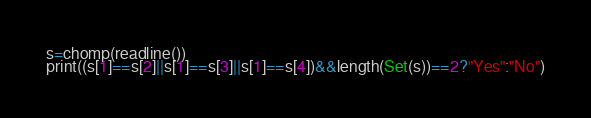Convert code to text. <code><loc_0><loc_0><loc_500><loc_500><_Julia_>s=chomp(readline())
print((s[1]==s[2]||s[1]==s[3]||s[1]==s[4])&&length(Set(s))==2?"Yes":"No")</code> 